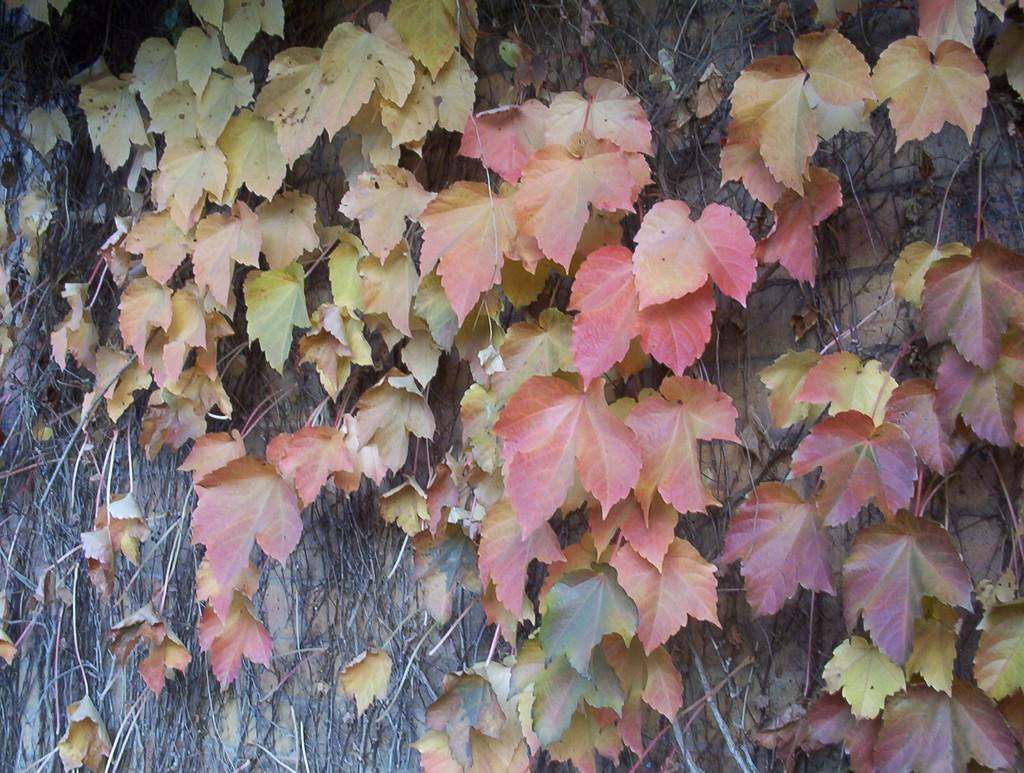What type of plants are represented in the image? The image contains leaves of creeper plants. Where are the leaves located? The leaves are on a wall. How many fingers are visible in the image? There are no fingers visible in the image; it only features leaves of creeper plants on a wall. 